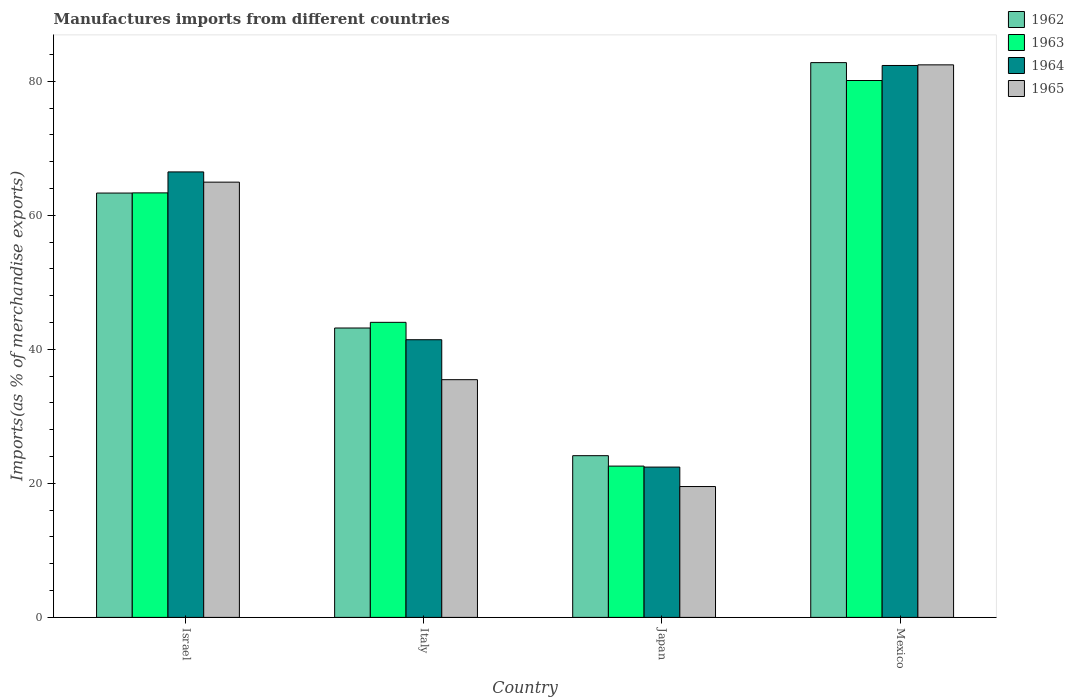How many different coloured bars are there?
Ensure brevity in your answer.  4. How many groups of bars are there?
Provide a short and direct response. 4. Are the number of bars on each tick of the X-axis equal?
Provide a succinct answer. Yes. How many bars are there on the 2nd tick from the left?
Your answer should be very brief. 4. How many bars are there on the 3rd tick from the right?
Offer a very short reply. 4. What is the label of the 1st group of bars from the left?
Give a very brief answer. Israel. What is the percentage of imports to different countries in 1962 in Italy?
Your response must be concise. 43.18. Across all countries, what is the maximum percentage of imports to different countries in 1965?
Your response must be concise. 82.44. Across all countries, what is the minimum percentage of imports to different countries in 1962?
Keep it short and to the point. 24.13. In which country was the percentage of imports to different countries in 1964 minimum?
Keep it short and to the point. Japan. What is the total percentage of imports to different countries in 1965 in the graph?
Provide a short and direct response. 202.38. What is the difference between the percentage of imports to different countries in 1965 in Israel and that in Mexico?
Provide a succinct answer. -17.5. What is the difference between the percentage of imports to different countries in 1965 in Italy and the percentage of imports to different countries in 1964 in Mexico?
Give a very brief answer. -46.88. What is the average percentage of imports to different countries in 1964 per country?
Keep it short and to the point. 53.17. What is the difference between the percentage of imports to different countries of/in 1963 and percentage of imports to different countries of/in 1962 in Italy?
Your answer should be very brief. 0.84. In how many countries, is the percentage of imports to different countries in 1963 greater than 44 %?
Provide a succinct answer. 3. What is the ratio of the percentage of imports to different countries in 1963 in Japan to that in Mexico?
Offer a terse response. 0.28. Is the percentage of imports to different countries in 1962 in Italy less than that in Mexico?
Offer a very short reply. Yes. What is the difference between the highest and the second highest percentage of imports to different countries in 1964?
Offer a very short reply. -40.92. What is the difference between the highest and the lowest percentage of imports to different countries in 1964?
Your answer should be compact. 59.92. In how many countries, is the percentage of imports to different countries in 1964 greater than the average percentage of imports to different countries in 1964 taken over all countries?
Offer a very short reply. 2. What does the 2nd bar from the left in Mexico represents?
Keep it short and to the point. 1963. What does the 1st bar from the right in Japan represents?
Make the answer very short. 1965. How many countries are there in the graph?
Your response must be concise. 4. What is the difference between two consecutive major ticks on the Y-axis?
Offer a terse response. 20. Does the graph contain any zero values?
Ensure brevity in your answer.  No. Does the graph contain grids?
Your answer should be compact. No. Where does the legend appear in the graph?
Make the answer very short. Top right. How many legend labels are there?
Offer a very short reply. 4. How are the legend labels stacked?
Make the answer very short. Vertical. What is the title of the graph?
Keep it short and to the point. Manufactures imports from different countries. What is the label or title of the Y-axis?
Make the answer very short. Imports(as % of merchandise exports). What is the Imports(as % of merchandise exports) of 1962 in Israel?
Make the answer very short. 63.32. What is the Imports(as % of merchandise exports) in 1963 in Israel?
Your response must be concise. 63.34. What is the Imports(as % of merchandise exports) of 1964 in Israel?
Your answer should be very brief. 66.47. What is the Imports(as % of merchandise exports) of 1965 in Israel?
Your response must be concise. 64.94. What is the Imports(as % of merchandise exports) of 1962 in Italy?
Your answer should be compact. 43.18. What is the Imports(as % of merchandise exports) in 1963 in Italy?
Offer a very short reply. 44.02. What is the Imports(as % of merchandise exports) in 1964 in Italy?
Ensure brevity in your answer.  41.43. What is the Imports(as % of merchandise exports) of 1965 in Italy?
Provide a short and direct response. 35.47. What is the Imports(as % of merchandise exports) in 1962 in Japan?
Ensure brevity in your answer.  24.13. What is the Imports(as % of merchandise exports) in 1963 in Japan?
Make the answer very short. 22.57. What is the Imports(as % of merchandise exports) in 1964 in Japan?
Ensure brevity in your answer.  22.43. What is the Imports(as % of merchandise exports) in 1965 in Japan?
Keep it short and to the point. 19.52. What is the Imports(as % of merchandise exports) in 1962 in Mexico?
Your response must be concise. 82.78. What is the Imports(as % of merchandise exports) in 1963 in Mexico?
Provide a succinct answer. 80.11. What is the Imports(as % of merchandise exports) of 1964 in Mexico?
Offer a very short reply. 82.35. What is the Imports(as % of merchandise exports) of 1965 in Mexico?
Make the answer very short. 82.44. Across all countries, what is the maximum Imports(as % of merchandise exports) in 1962?
Offer a terse response. 82.78. Across all countries, what is the maximum Imports(as % of merchandise exports) of 1963?
Your response must be concise. 80.11. Across all countries, what is the maximum Imports(as % of merchandise exports) of 1964?
Offer a terse response. 82.35. Across all countries, what is the maximum Imports(as % of merchandise exports) of 1965?
Offer a terse response. 82.44. Across all countries, what is the minimum Imports(as % of merchandise exports) in 1962?
Keep it short and to the point. 24.13. Across all countries, what is the minimum Imports(as % of merchandise exports) of 1963?
Give a very brief answer. 22.57. Across all countries, what is the minimum Imports(as % of merchandise exports) of 1964?
Your answer should be compact. 22.43. Across all countries, what is the minimum Imports(as % of merchandise exports) in 1965?
Your response must be concise. 19.52. What is the total Imports(as % of merchandise exports) in 1962 in the graph?
Make the answer very short. 213.4. What is the total Imports(as % of merchandise exports) of 1963 in the graph?
Your answer should be compact. 210.05. What is the total Imports(as % of merchandise exports) in 1964 in the graph?
Make the answer very short. 212.68. What is the total Imports(as % of merchandise exports) in 1965 in the graph?
Keep it short and to the point. 202.38. What is the difference between the Imports(as % of merchandise exports) of 1962 in Israel and that in Italy?
Your answer should be compact. 20.14. What is the difference between the Imports(as % of merchandise exports) of 1963 in Israel and that in Italy?
Provide a short and direct response. 19.32. What is the difference between the Imports(as % of merchandise exports) in 1964 in Israel and that in Italy?
Your answer should be very brief. 25.04. What is the difference between the Imports(as % of merchandise exports) in 1965 in Israel and that in Italy?
Your response must be concise. 29.47. What is the difference between the Imports(as % of merchandise exports) of 1962 in Israel and that in Japan?
Make the answer very short. 39.19. What is the difference between the Imports(as % of merchandise exports) of 1963 in Israel and that in Japan?
Your answer should be very brief. 40.77. What is the difference between the Imports(as % of merchandise exports) in 1964 in Israel and that in Japan?
Offer a very short reply. 44.04. What is the difference between the Imports(as % of merchandise exports) of 1965 in Israel and that in Japan?
Your response must be concise. 45.42. What is the difference between the Imports(as % of merchandise exports) in 1962 in Israel and that in Mexico?
Make the answer very short. -19.46. What is the difference between the Imports(as % of merchandise exports) in 1963 in Israel and that in Mexico?
Your response must be concise. -16.77. What is the difference between the Imports(as % of merchandise exports) of 1964 in Israel and that in Mexico?
Offer a terse response. -15.88. What is the difference between the Imports(as % of merchandise exports) of 1965 in Israel and that in Mexico?
Your answer should be very brief. -17.5. What is the difference between the Imports(as % of merchandise exports) in 1962 in Italy and that in Japan?
Keep it short and to the point. 19.05. What is the difference between the Imports(as % of merchandise exports) in 1963 in Italy and that in Japan?
Make the answer very short. 21.45. What is the difference between the Imports(as % of merchandise exports) in 1964 in Italy and that in Japan?
Provide a short and direct response. 19. What is the difference between the Imports(as % of merchandise exports) of 1965 in Italy and that in Japan?
Offer a very short reply. 15.94. What is the difference between the Imports(as % of merchandise exports) in 1962 in Italy and that in Mexico?
Your answer should be compact. -39.6. What is the difference between the Imports(as % of merchandise exports) in 1963 in Italy and that in Mexico?
Provide a succinct answer. -36.08. What is the difference between the Imports(as % of merchandise exports) in 1964 in Italy and that in Mexico?
Keep it short and to the point. -40.92. What is the difference between the Imports(as % of merchandise exports) of 1965 in Italy and that in Mexico?
Offer a very short reply. -46.98. What is the difference between the Imports(as % of merchandise exports) of 1962 in Japan and that in Mexico?
Your answer should be compact. -58.65. What is the difference between the Imports(as % of merchandise exports) of 1963 in Japan and that in Mexico?
Offer a very short reply. -57.53. What is the difference between the Imports(as % of merchandise exports) of 1964 in Japan and that in Mexico?
Offer a terse response. -59.92. What is the difference between the Imports(as % of merchandise exports) of 1965 in Japan and that in Mexico?
Keep it short and to the point. -62.92. What is the difference between the Imports(as % of merchandise exports) in 1962 in Israel and the Imports(as % of merchandise exports) in 1963 in Italy?
Keep it short and to the point. 19.29. What is the difference between the Imports(as % of merchandise exports) in 1962 in Israel and the Imports(as % of merchandise exports) in 1964 in Italy?
Keep it short and to the point. 21.88. What is the difference between the Imports(as % of merchandise exports) in 1962 in Israel and the Imports(as % of merchandise exports) in 1965 in Italy?
Your answer should be compact. 27.85. What is the difference between the Imports(as % of merchandise exports) of 1963 in Israel and the Imports(as % of merchandise exports) of 1964 in Italy?
Offer a terse response. 21.91. What is the difference between the Imports(as % of merchandise exports) of 1963 in Israel and the Imports(as % of merchandise exports) of 1965 in Italy?
Make the answer very short. 27.87. What is the difference between the Imports(as % of merchandise exports) of 1964 in Israel and the Imports(as % of merchandise exports) of 1965 in Italy?
Offer a terse response. 31. What is the difference between the Imports(as % of merchandise exports) in 1962 in Israel and the Imports(as % of merchandise exports) in 1963 in Japan?
Keep it short and to the point. 40.74. What is the difference between the Imports(as % of merchandise exports) of 1962 in Israel and the Imports(as % of merchandise exports) of 1964 in Japan?
Keep it short and to the point. 40.89. What is the difference between the Imports(as % of merchandise exports) of 1962 in Israel and the Imports(as % of merchandise exports) of 1965 in Japan?
Give a very brief answer. 43.79. What is the difference between the Imports(as % of merchandise exports) of 1963 in Israel and the Imports(as % of merchandise exports) of 1964 in Japan?
Offer a very short reply. 40.91. What is the difference between the Imports(as % of merchandise exports) of 1963 in Israel and the Imports(as % of merchandise exports) of 1965 in Japan?
Offer a terse response. 43.82. What is the difference between the Imports(as % of merchandise exports) in 1964 in Israel and the Imports(as % of merchandise exports) in 1965 in Japan?
Offer a very short reply. 46.94. What is the difference between the Imports(as % of merchandise exports) of 1962 in Israel and the Imports(as % of merchandise exports) of 1963 in Mexico?
Offer a terse response. -16.79. What is the difference between the Imports(as % of merchandise exports) in 1962 in Israel and the Imports(as % of merchandise exports) in 1964 in Mexico?
Your response must be concise. -19.03. What is the difference between the Imports(as % of merchandise exports) of 1962 in Israel and the Imports(as % of merchandise exports) of 1965 in Mexico?
Offer a very short reply. -19.13. What is the difference between the Imports(as % of merchandise exports) of 1963 in Israel and the Imports(as % of merchandise exports) of 1964 in Mexico?
Provide a succinct answer. -19.01. What is the difference between the Imports(as % of merchandise exports) of 1963 in Israel and the Imports(as % of merchandise exports) of 1965 in Mexico?
Make the answer very short. -19.1. What is the difference between the Imports(as % of merchandise exports) in 1964 in Israel and the Imports(as % of merchandise exports) in 1965 in Mexico?
Offer a terse response. -15.98. What is the difference between the Imports(as % of merchandise exports) of 1962 in Italy and the Imports(as % of merchandise exports) of 1963 in Japan?
Your response must be concise. 20.61. What is the difference between the Imports(as % of merchandise exports) in 1962 in Italy and the Imports(as % of merchandise exports) in 1964 in Japan?
Make the answer very short. 20.75. What is the difference between the Imports(as % of merchandise exports) in 1962 in Italy and the Imports(as % of merchandise exports) in 1965 in Japan?
Provide a succinct answer. 23.66. What is the difference between the Imports(as % of merchandise exports) of 1963 in Italy and the Imports(as % of merchandise exports) of 1964 in Japan?
Offer a terse response. 21.6. What is the difference between the Imports(as % of merchandise exports) in 1963 in Italy and the Imports(as % of merchandise exports) in 1965 in Japan?
Provide a short and direct response. 24.5. What is the difference between the Imports(as % of merchandise exports) in 1964 in Italy and the Imports(as % of merchandise exports) in 1965 in Japan?
Make the answer very short. 21.91. What is the difference between the Imports(as % of merchandise exports) of 1962 in Italy and the Imports(as % of merchandise exports) of 1963 in Mexico?
Provide a succinct answer. -36.93. What is the difference between the Imports(as % of merchandise exports) in 1962 in Italy and the Imports(as % of merchandise exports) in 1964 in Mexico?
Provide a succinct answer. -39.17. What is the difference between the Imports(as % of merchandise exports) of 1962 in Italy and the Imports(as % of merchandise exports) of 1965 in Mexico?
Make the answer very short. -39.26. What is the difference between the Imports(as % of merchandise exports) in 1963 in Italy and the Imports(as % of merchandise exports) in 1964 in Mexico?
Make the answer very short. -38.33. What is the difference between the Imports(as % of merchandise exports) of 1963 in Italy and the Imports(as % of merchandise exports) of 1965 in Mexico?
Your answer should be compact. -38.42. What is the difference between the Imports(as % of merchandise exports) in 1964 in Italy and the Imports(as % of merchandise exports) in 1965 in Mexico?
Provide a succinct answer. -41.01. What is the difference between the Imports(as % of merchandise exports) in 1962 in Japan and the Imports(as % of merchandise exports) in 1963 in Mexico?
Offer a terse response. -55.98. What is the difference between the Imports(as % of merchandise exports) in 1962 in Japan and the Imports(as % of merchandise exports) in 1964 in Mexico?
Your response must be concise. -58.22. What is the difference between the Imports(as % of merchandise exports) of 1962 in Japan and the Imports(as % of merchandise exports) of 1965 in Mexico?
Provide a succinct answer. -58.32. What is the difference between the Imports(as % of merchandise exports) in 1963 in Japan and the Imports(as % of merchandise exports) in 1964 in Mexico?
Keep it short and to the point. -59.78. What is the difference between the Imports(as % of merchandise exports) of 1963 in Japan and the Imports(as % of merchandise exports) of 1965 in Mexico?
Offer a very short reply. -59.87. What is the difference between the Imports(as % of merchandise exports) of 1964 in Japan and the Imports(as % of merchandise exports) of 1965 in Mexico?
Your answer should be very brief. -60.02. What is the average Imports(as % of merchandise exports) in 1962 per country?
Offer a terse response. 53.35. What is the average Imports(as % of merchandise exports) in 1963 per country?
Offer a terse response. 52.51. What is the average Imports(as % of merchandise exports) of 1964 per country?
Your response must be concise. 53.17. What is the average Imports(as % of merchandise exports) in 1965 per country?
Offer a terse response. 50.6. What is the difference between the Imports(as % of merchandise exports) of 1962 and Imports(as % of merchandise exports) of 1963 in Israel?
Your response must be concise. -0.02. What is the difference between the Imports(as % of merchandise exports) of 1962 and Imports(as % of merchandise exports) of 1964 in Israel?
Your response must be concise. -3.15. What is the difference between the Imports(as % of merchandise exports) in 1962 and Imports(as % of merchandise exports) in 1965 in Israel?
Provide a succinct answer. -1.63. What is the difference between the Imports(as % of merchandise exports) in 1963 and Imports(as % of merchandise exports) in 1964 in Israel?
Make the answer very short. -3.13. What is the difference between the Imports(as % of merchandise exports) of 1963 and Imports(as % of merchandise exports) of 1965 in Israel?
Provide a short and direct response. -1.6. What is the difference between the Imports(as % of merchandise exports) in 1964 and Imports(as % of merchandise exports) in 1965 in Israel?
Provide a succinct answer. 1.53. What is the difference between the Imports(as % of merchandise exports) in 1962 and Imports(as % of merchandise exports) in 1963 in Italy?
Keep it short and to the point. -0.84. What is the difference between the Imports(as % of merchandise exports) in 1962 and Imports(as % of merchandise exports) in 1964 in Italy?
Ensure brevity in your answer.  1.75. What is the difference between the Imports(as % of merchandise exports) in 1962 and Imports(as % of merchandise exports) in 1965 in Italy?
Give a very brief answer. 7.71. What is the difference between the Imports(as % of merchandise exports) in 1963 and Imports(as % of merchandise exports) in 1964 in Italy?
Offer a terse response. 2.59. What is the difference between the Imports(as % of merchandise exports) in 1963 and Imports(as % of merchandise exports) in 1965 in Italy?
Your answer should be compact. 8.56. What is the difference between the Imports(as % of merchandise exports) in 1964 and Imports(as % of merchandise exports) in 1965 in Italy?
Your answer should be very brief. 5.96. What is the difference between the Imports(as % of merchandise exports) in 1962 and Imports(as % of merchandise exports) in 1963 in Japan?
Make the answer very short. 1.55. What is the difference between the Imports(as % of merchandise exports) in 1962 and Imports(as % of merchandise exports) in 1964 in Japan?
Your response must be concise. 1.7. What is the difference between the Imports(as % of merchandise exports) in 1962 and Imports(as % of merchandise exports) in 1965 in Japan?
Your answer should be very brief. 4.6. What is the difference between the Imports(as % of merchandise exports) of 1963 and Imports(as % of merchandise exports) of 1964 in Japan?
Your response must be concise. 0.15. What is the difference between the Imports(as % of merchandise exports) of 1963 and Imports(as % of merchandise exports) of 1965 in Japan?
Make the answer very short. 3.05. What is the difference between the Imports(as % of merchandise exports) of 1964 and Imports(as % of merchandise exports) of 1965 in Japan?
Provide a short and direct response. 2.9. What is the difference between the Imports(as % of merchandise exports) of 1962 and Imports(as % of merchandise exports) of 1963 in Mexico?
Provide a succinct answer. 2.67. What is the difference between the Imports(as % of merchandise exports) of 1962 and Imports(as % of merchandise exports) of 1964 in Mexico?
Make the answer very short. 0.43. What is the difference between the Imports(as % of merchandise exports) of 1962 and Imports(as % of merchandise exports) of 1965 in Mexico?
Keep it short and to the point. 0.33. What is the difference between the Imports(as % of merchandise exports) of 1963 and Imports(as % of merchandise exports) of 1964 in Mexico?
Ensure brevity in your answer.  -2.24. What is the difference between the Imports(as % of merchandise exports) in 1963 and Imports(as % of merchandise exports) in 1965 in Mexico?
Your answer should be compact. -2.34. What is the difference between the Imports(as % of merchandise exports) in 1964 and Imports(as % of merchandise exports) in 1965 in Mexico?
Give a very brief answer. -0.09. What is the ratio of the Imports(as % of merchandise exports) in 1962 in Israel to that in Italy?
Provide a succinct answer. 1.47. What is the ratio of the Imports(as % of merchandise exports) of 1963 in Israel to that in Italy?
Your response must be concise. 1.44. What is the ratio of the Imports(as % of merchandise exports) in 1964 in Israel to that in Italy?
Your response must be concise. 1.6. What is the ratio of the Imports(as % of merchandise exports) in 1965 in Israel to that in Italy?
Provide a succinct answer. 1.83. What is the ratio of the Imports(as % of merchandise exports) in 1962 in Israel to that in Japan?
Offer a very short reply. 2.62. What is the ratio of the Imports(as % of merchandise exports) in 1963 in Israel to that in Japan?
Ensure brevity in your answer.  2.81. What is the ratio of the Imports(as % of merchandise exports) of 1964 in Israel to that in Japan?
Your answer should be compact. 2.96. What is the ratio of the Imports(as % of merchandise exports) in 1965 in Israel to that in Japan?
Provide a short and direct response. 3.33. What is the ratio of the Imports(as % of merchandise exports) in 1962 in Israel to that in Mexico?
Ensure brevity in your answer.  0.76. What is the ratio of the Imports(as % of merchandise exports) in 1963 in Israel to that in Mexico?
Offer a terse response. 0.79. What is the ratio of the Imports(as % of merchandise exports) of 1964 in Israel to that in Mexico?
Offer a terse response. 0.81. What is the ratio of the Imports(as % of merchandise exports) of 1965 in Israel to that in Mexico?
Provide a short and direct response. 0.79. What is the ratio of the Imports(as % of merchandise exports) of 1962 in Italy to that in Japan?
Give a very brief answer. 1.79. What is the ratio of the Imports(as % of merchandise exports) in 1963 in Italy to that in Japan?
Provide a succinct answer. 1.95. What is the ratio of the Imports(as % of merchandise exports) in 1964 in Italy to that in Japan?
Provide a short and direct response. 1.85. What is the ratio of the Imports(as % of merchandise exports) in 1965 in Italy to that in Japan?
Provide a short and direct response. 1.82. What is the ratio of the Imports(as % of merchandise exports) in 1962 in Italy to that in Mexico?
Ensure brevity in your answer.  0.52. What is the ratio of the Imports(as % of merchandise exports) of 1963 in Italy to that in Mexico?
Keep it short and to the point. 0.55. What is the ratio of the Imports(as % of merchandise exports) in 1964 in Italy to that in Mexico?
Keep it short and to the point. 0.5. What is the ratio of the Imports(as % of merchandise exports) in 1965 in Italy to that in Mexico?
Your answer should be compact. 0.43. What is the ratio of the Imports(as % of merchandise exports) in 1962 in Japan to that in Mexico?
Provide a short and direct response. 0.29. What is the ratio of the Imports(as % of merchandise exports) in 1963 in Japan to that in Mexico?
Your answer should be compact. 0.28. What is the ratio of the Imports(as % of merchandise exports) of 1964 in Japan to that in Mexico?
Keep it short and to the point. 0.27. What is the ratio of the Imports(as % of merchandise exports) of 1965 in Japan to that in Mexico?
Keep it short and to the point. 0.24. What is the difference between the highest and the second highest Imports(as % of merchandise exports) of 1962?
Provide a succinct answer. 19.46. What is the difference between the highest and the second highest Imports(as % of merchandise exports) in 1963?
Offer a terse response. 16.77. What is the difference between the highest and the second highest Imports(as % of merchandise exports) of 1964?
Keep it short and to the point. 15.88. What is the difference between the highest and the second highest Imports(as % of merchandise exports) in 1965?
Your response must be concise. 17.5. What is the difference between the highest and the lowest Imports(as % of merchandise exports) of 1962?
Your answer should be compact. 58.65. What is the difference between the highest and the lowest Imports(as % of merchandise exports) of 1963?
Provide a succinct answer. 57.53. What is the difference between the highest and the lowest Imports(as % of merchandise exports) of 1964?
Your answer should be compact. 59.92. What is the difference between the highest and the lowest Imports(as % of merchandise exports) in 1965?
Give a very brief answer. 62.92. 